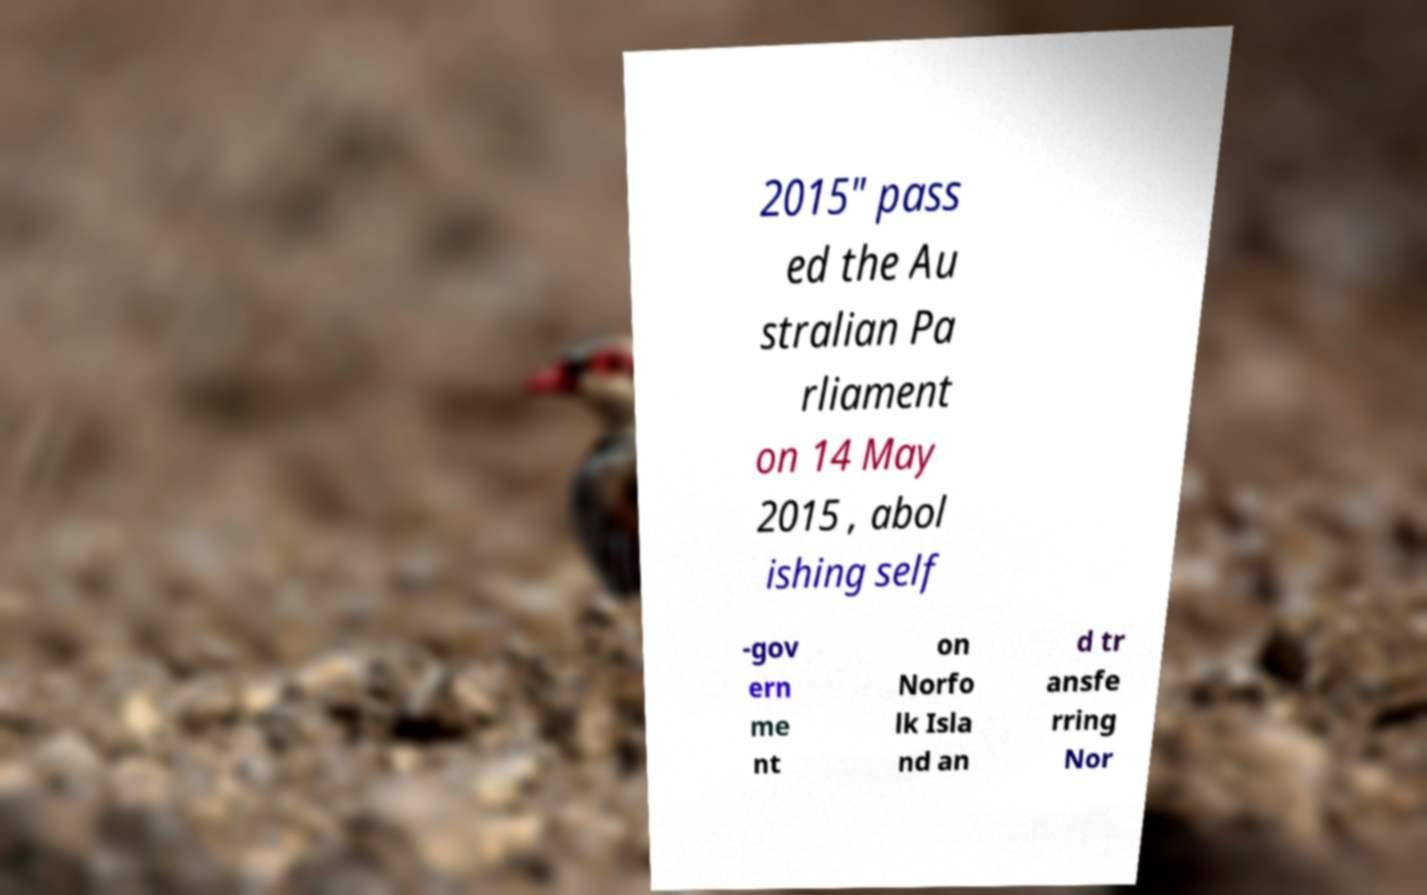Can you read and provide the text displayed in the image?This photo seems to have some interesting text. Can you extract and type it out for me? 2015" pass ed the Au stralian Pa rliament on 14 May 2015 , abol ishing self -gov ern me nt on Norfo lk Isla nd an d tr ansfe rring Nor 